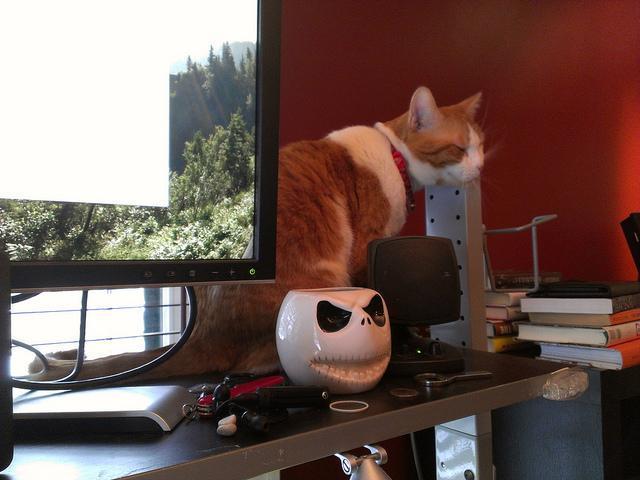What word is appropriate to describe the animal near the books?
Make your selection and explain in format: 'Answer: answer
Rationale: rationale.'
Options: Squid, invertebrate, mammal, mollusk. Answer: mammal.
Rationale: The word is a mammal. 